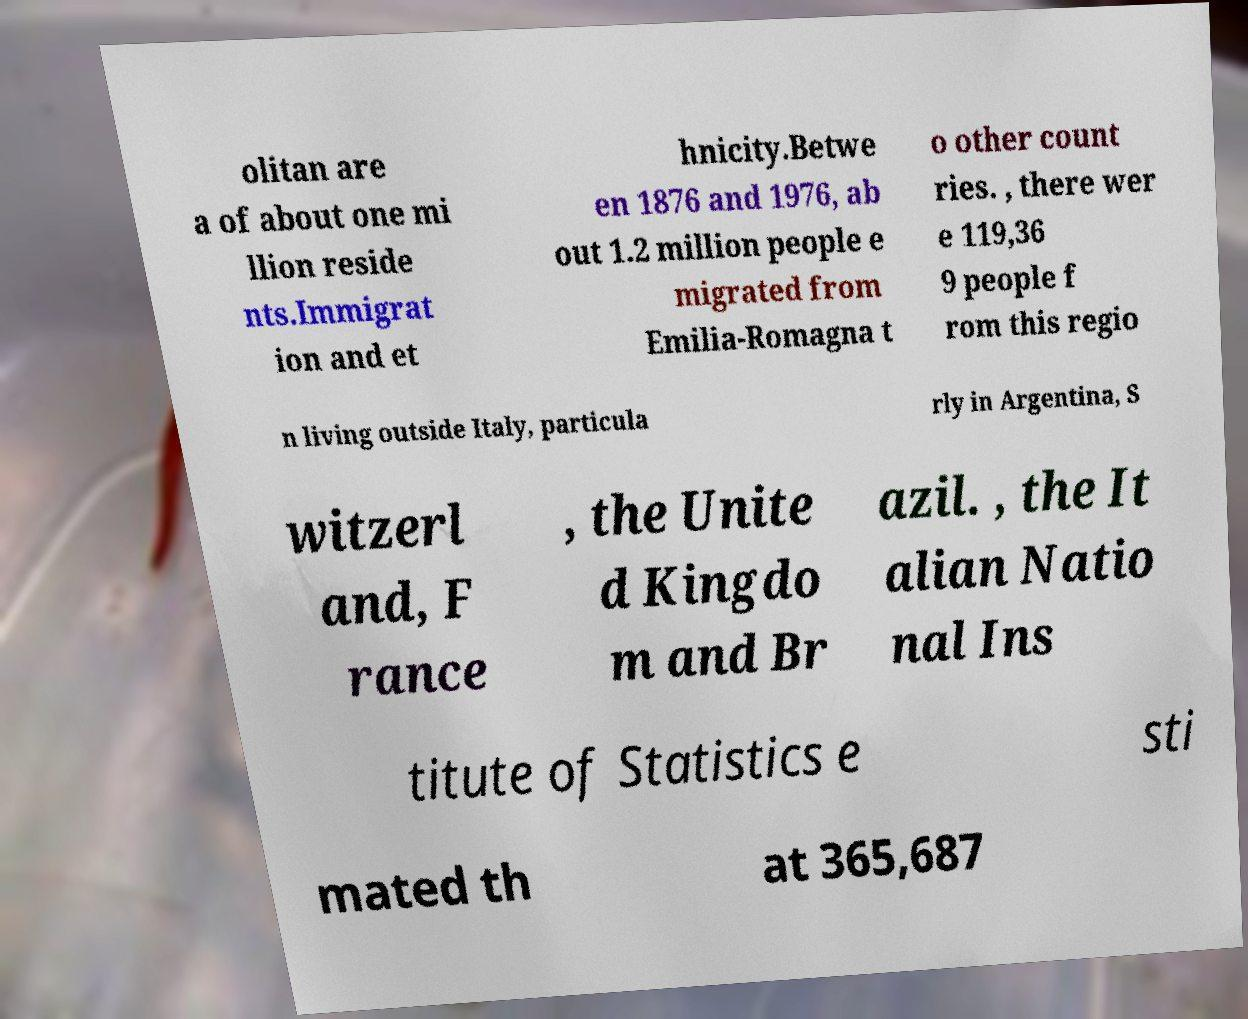Please identify and transcribe the text found in this image. olitan are a of about one mi llion reside nts.Immigrat ion and et hnicity.Betwe en 1876 and 1976, ab out 1.2 million people e migrated from Emilia-Romagna t o other count ries. , there wer e 119,36 9 people f rom this regio n living outside Italy, particula rly in Argentina, S witzerl and, F rance , the Unite d Kingdo m and Br azil. , the It alian Natio nal Ins titute of Statistics e sti mated th at 365,687 